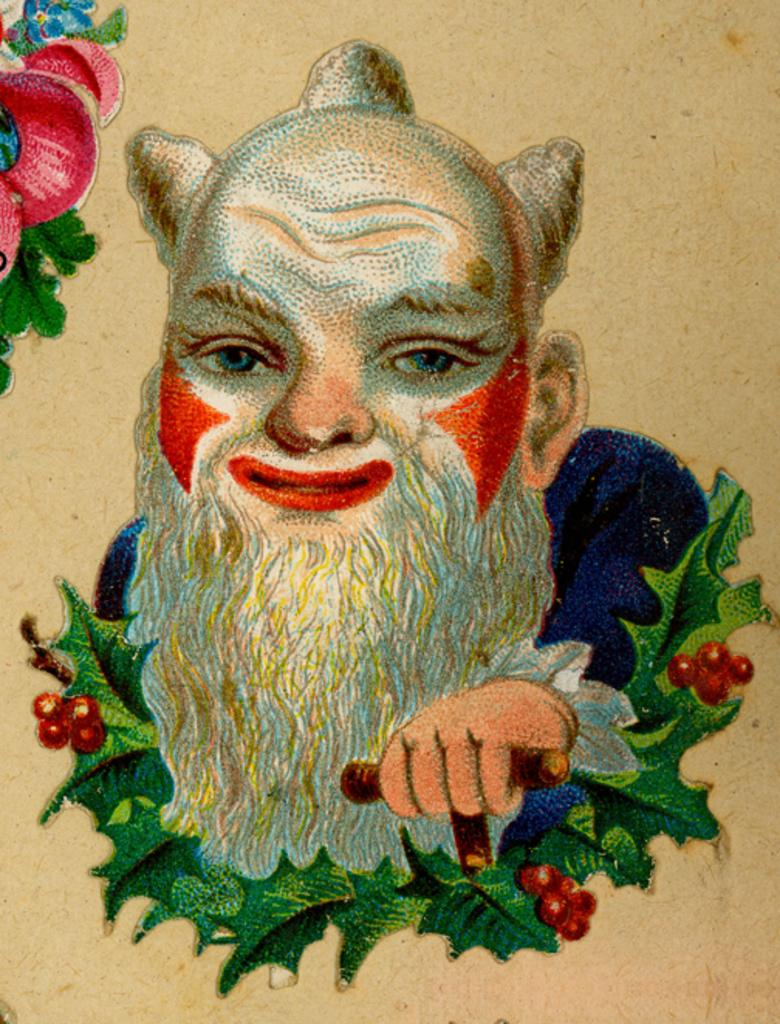What is the main subject of the image? The image contains a painting. What is depicted in the painting? The painting depicts a person's head and hand. What other elements are included in the painting? The painting includes leaves and fruits. What is the color of the background in the painting? The background of the painting is white. What can be seen in the top left-hand corner of the image? There are leaves and flowers in the top left-hand corner of the image. What type of industry is depicted in the painting? There is no industry depicted in the painting; it features a person's head and hand, leaves, and fruits. Can you tell me how the person in the painting is trying to escape from the quicksand? There is no quicksand present in the painting; it features a person's head and hand, leaves, and fruits against a white background. 